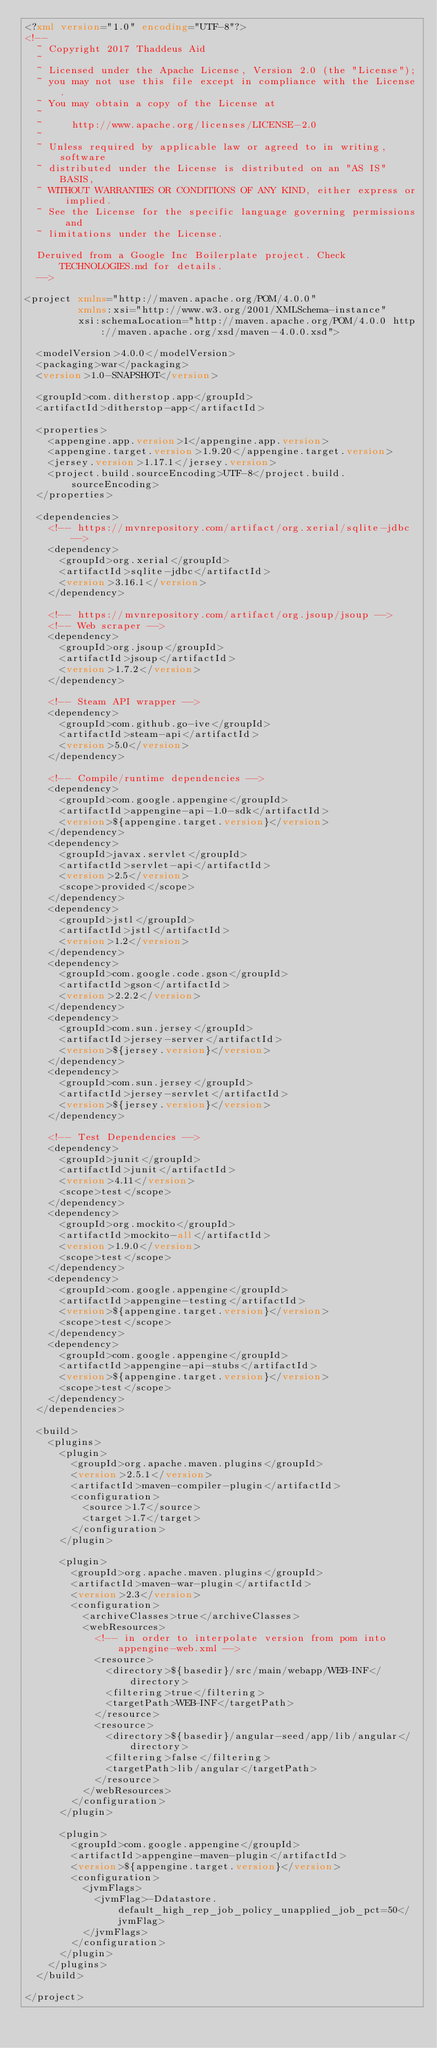Convert code to text. <code><loc_0><loc_0><loc_500><loc_500><_XML_><?xml version="1.0" encoding="UTF-8"?>
<!--
  ~ Copyright 2017 Thaddeus Aid
  ~
  ~ Licensed under the Apache License, Version 2.0 (the "License");
  ~ you may not use this file except in compliance with the License.
  ~ You may obtain a copy of the License at
  ~
  ~     http://www.apache.org/licenses/LICENSE-2.0
  ~
  ~ Unless required by applicable law or agreed to in writing, software
  ~ distributed under the License is distributed on an "AS IS" BASIS,
  ~ WITHOUT WARRANTIES OR CONDITIONS OF ANY KIND, either express or implied.
  ~ See the License for the specific language governing permissions and
  ~ limitations under the License.

  Deruived from a Google Inc Boilerplate project. Check TECHNOLOGIES.md for details.
  -->

<project xmlns="http://maven.apache.org/POM/4.0.0"
         xmlns:xsi="http://www.w3.org/2001/XMLSchema-instance"
         xsi:schemaLocation="http://maven.apache.org/POM/4.0.0 http://maven.apache.org/xsd/maven-4.0.0.xsd">

  <modelVersion>4.0.0</modelVersion>
  <packaging>war</packaging>
  <version>1.0-SNAPSHOT</version>

  <groupId>com.ditherstop.app</groupId>
  <artifactId>ditherstop-app</artifactId>

  <properties>
    <appengine.app.version>1</appengine.app.version>
    <appengine.target.version>1.9.20</appengine.target.version>
    <jersey.version>1.17.1</jersey.version>
    <project.build.sourceEncoding>UTF-8</project.build.sourceEncoding>
  </properties>

  <dependencies>
    <!-- https://mvnrepository.com/artifact/org.xerial/sqlite-jdbc -->
    <dependency>
      <groupId>org.xerial</groupId>
      <artifactId>sqlite-jdbc</artifactId>
      <version>3.16.1</version>
    </dependency>

    <!-- https://mvnrepository.com/artifact/org.jsoup/jsoup -->
    <!-- Web scraper -->
    <dependency>
      <groupId>org.jsoup</groupId>
      <artifactId>jsoup</artifactId>
      <version>1.7.2</version>
    </dependency>

    <!-- Steam API wrapper -->
    <dependency>
      <groupId>com.github.go-ive</groupId>
      <artifactId>steam-api</artifactId>
      <version>5.0</version>
    </dependency>

    <!-- Compile/runtime dependencies -->
    <dependency>
      <groupId>com.google.appengine</groupId>
      <artifactId>appengine-api-1.0-sdk</artifactId>
      <version>${appengine.target.version}</version>
    </dependency>
    <dependency>
      <groupId>javax.servlet</groupId>
      <artifactId>servlet-api</artifactId>
      <version>2.5</version>
      <scope>provided</scope>
    </dependency>
    <dependency>
      <groupId>jstl</groupId>
      <artifactId>jstl</artifactId>
      <version>1.2</version>
    </dependency>
    <dependency>
      <groupId>com.google.code.gson</groupId>
      <artifactId>gson</artifactId>
      <version>2.2.2</version>
    </dependency>
    <dependency>
      <groupId>com.sun.jersey</groupId>
      <artifactId>jersey-server</artifactId>
      <version>${jersey.version}</version>
    </dependency>
    <dependency>
      <groupId>com.sun.jersey</groupId>
      <artifactId>jersey-servlet</artifactId>
      <version>${jersey.version}</version>
    </dependency>

    <!-- Test Dependencies -->
    <dependency>
      <groupId>junit</groupId>
      <artifactId>junit</artifactId>
      <version>4.11</version>
      <scope>test</scope>
    </dependency>
    <dependency>
      <groupId>org.mockito</groupId>
      <artifactId>mockito-all</artifactId>
      <version>1.9.0</version>
      <scope>test</scope>
    </dependency>
    <dependency>
      <groupId>com.google.appengine</groupId>
      <artifactId>appengine-testing</artifactId>
      <version>${appengine.target.version}</version>
      <scope>test</scope>
    </dependency>
    <dependency>
      <groupId>com.google.appengine</groupId>
      <artifactId>appengine-api-stubs</artifactId>
      <version>${appengine.target.version}</version>
      <scope>test</scope>
    </dependency>
  </dependencies>

  <build>
    <plugins>
      <plugin>
        <groupId>org.apache.maven.plugins</groupId>
        <version>2.5.1</version>
        <artifactId>maven-compiler-plugin</artifactId>
        <configuration>
          <source>1.7</source>
          <target>1.7</target>
        </configuration>
      </plugin>

      <plugin>
        <groupId>org.apache.maven.plugins</groupId>
        <artifactId>maven-war-plugin</artifactId>
        <version>2.3</version>
        <configuration>
          <archiveClasses>true</archiveClasses>
          <webResources>
            <!-- in order to interpolate version from pom into appengine-web.xml -->
            <resource>
              <directory>${basedir}/src/main/webapp/WEB-INF</directory>
              <filtering>true</filtering>
              <targetPath>WEB-INF</targetPath>
            </resource>
            <resource>
              <directory>${basedir}/angular-seed/app/lib/angular</directory>
              <filtering>false</filtering>
              <targetPath>lib/angular</targetPath>
            </resource>
          </webResources>
        </configuration>
      </plugin>

      <plugin>
        <groupId>com.google.appengine</groupId>
        <artifactId>appengine-maven-plugin</artifactId>
        <version>${appengine.target.version}</version>
        <configuration>
          <jvmFlags>
            <jvmFlag>-Ddatastore.default_high_rep_job_policy_unapplied_job_pct=50</jvmFlag>
          </jvmFlags>
        </configuration>
      </plugin>
    </plugins>
  </build>

</project>
</code> 